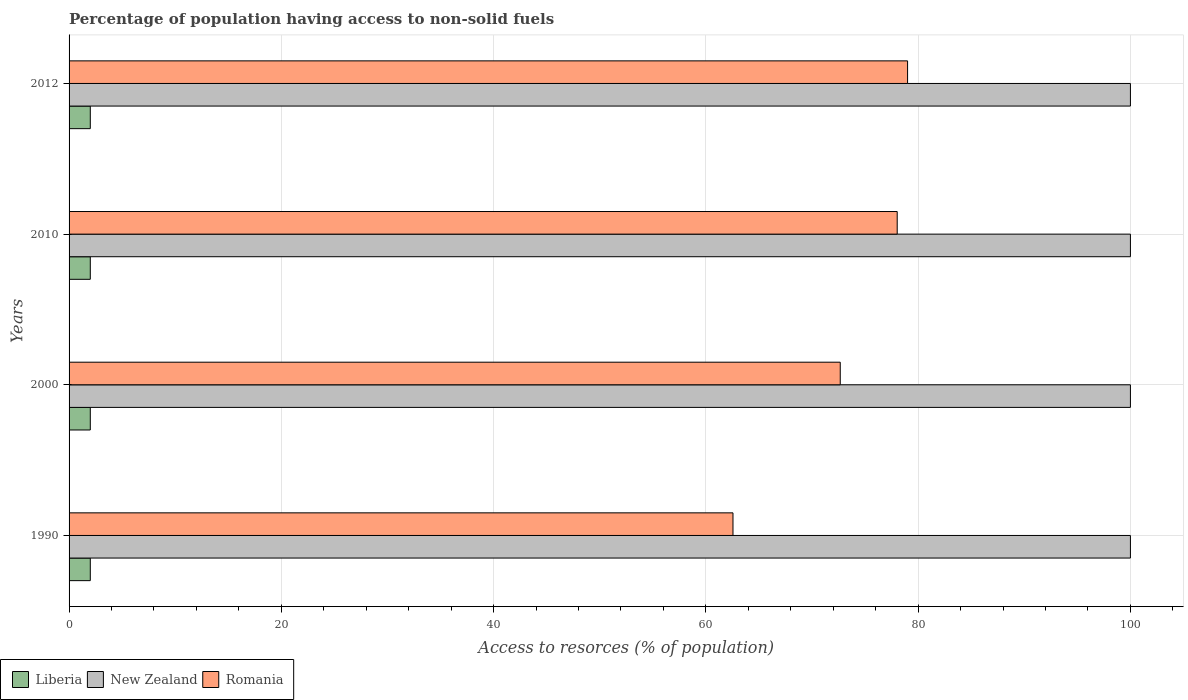How many different coloured bars are there?
Offer a very short reply. 3. How many groups of bars are there?
Keep it short and to the point. 4. Are the number of bars on each tick of the Y-axis equal?
Your answer should be compact. Yes. What is the label of the 2nd group of bars from the top?
Your answer should be compact. 2010. In how many cases, is the number of bars for a given year not equal to the number of legend labels?
Offer a terse response. 0. What is the percentage of population having access to non-solid fuels in Liberia in 2010?
Your response must be concise. 2. Across all years, what is the maximum percentage of population having access to non-solid fuels in Liberia?
Offer a very short reply. 2. Across all years, what is the minimum percentage of population having access to non-solid fuels in Romania?
Offer a very short reply. 62.55. In which year was the percentage of population having access to non-solid fuels in Liberia maximum?
Make the answer very short. 1990. In which year was the percentage of population having access to non-solid fuels in New Zealand minimum?
Make the answer very short. 1990. What is the total percentage of population having access to non-solid fuels in Liberia in the graph?
Your answer should be compact. 8. What is the difference between the percentage of population having access to non-solid fuels in Romania in 2010 and the percentage of population having access to non-solid fuels in Liberia in 2012?
Make the answer very short. 76.03. In the year 2000, what is the difference between the percentage of population having access to non-solid fuels in New Zealand and percentage of population having access to non-solid fuels in Romania?
Your answer should be very brief. 27.34. In how many years, is the percentage of population having access to non-solid fuels in Romania greater than 60 %?
Provide a short and direct response. 4. What is the ratio of the percentage of population having access to non-solid fuels in New Zealand in 1990 to that in 2000?
Keep it short and to the point. 1. Is the percentage of population having access to non-solid fuels in New Zealand in 1990 less than that in 2012?
Make the answer very short. No. Is the difference between the percentage of population having access to non-solid fuels in New Zealand in 2000 and 2010 greater than the difference between the percentage of population having access to non-solid fuels in Romania in 2000 and 2010?
Provide a succinct answer. Yes. What is the difference between the highest and the second highest percentage of population having access to non-solid fuels in New Zealand?
Provide a succinct answer. 0. What is the difference between the highest and the lowest percentage of population having access to non-solid fuels in Liberia?
Make the answer very short. 0. What does the 1st bar from the top in 2012 represents?
Keep it short and to the point. Romania. What does the 2nd bar from the bottom in 2000 represents?
Provide a succinct answer. New Zealand. Is it the case that in every year, the sum of the percentage of population having access to non-solid fuels in New Zealand and percentage of population having access to non-solid fuels in Romania is greater than the percentage of population having access to non-solid fuels in Liberia?
Your answer should be very brief. Yes. How many years are there in the graph?
Give a very brief answer. 4. Are the values on the major ticks of X-axis written in scientific E-notation?
Offer a terse response. No. Does the graph contain grids?
Provide a succinct answer. Yes. Where does the legend appear in the graph?
Your answer should be very brief. Bottom left. What is the title of the graph?
Your response must be concise. Percentage of population having access to non-solid fuels. What is the label or title of the X-axis?
Offer a terse response. Access to resorces (% of population). What is the Access to resorces (% of population) in Liberia in 1990?
Offer a very short reply. 2. What is the Access to resorces (% of population) of New Zealand in 1990?
Your response must be concise. 100. What is the Access to resorces (% of population) in Romania in 1990?
Make the answer very short. 62.55. What is the Access to resorces (% of population) of Liberia in 2000?
Offer a very short reply. 2. What is the Access to resorces (% of population) in New Zealand in 2000?
Give a very brief answer. 100. What is the Access to resorces (% of population) in Romania in 2000?
Your response must be concise. 72.66. What is the Access to resorces (% of population) in Liberia in 2010?
Offer a terse response. 2. What is the Access to resorces (% of population) in New Zealand in 2010?
Your answer should be very brief. 100. What is the Access to resorces (% of population) of Romania in 2010?
Your response must be concise. 78.03. What is the Access to resorces (% of population) in Liberia in 2012?
Provide a succinct answer. 2. What is the Access to resorces (% of population) in New Zealand in 2012?
Offer a terse response. 100. What is the Access to resorces (% of population) of Romania in 2012?
Give a very brief answer. 79. Across all years, what is the maximum Access to resorces (% of population) of Liberia?
Provide a succinct answer. 2. Across all years, what is the maximum Access to resorces (% of population) of New Zealand?
Provide a succinct answer. 100. Across all years, what is the maximum Access to resorces (% of population) in Romania?
Make the answer very short. 79. Across all years, what is the minimum Access to resorces (% of population) of Liberia?
Provide a short and direct response. 2. Across all years, what is the minimum Access to resorces (% of population) in Romania?
Your response must be concise. 62.55. What is the total Access to resorces (% of population) of Romania in the graph?
Give a very brief answer. 292.24. What is the difference between the Access to resorces (% of population) of New Zealand in 1990 and that in 2000?
Provide a succinct answer. 0. What is the difference between the Access to resorces (% of population) in Romania in 1990 and that in 2000?
Ensure brevity in your answer.  -10.11. What is the difference between the Access to resorces (% of population) in Liberia in 1990 and that in 2010?
Ensure brevity in your answer.  0. What is the difference between the Access to resorces (% of population) in New Zealand in 1990 and that in 2010?
Offer a very short reply. 0. What is the difference between the Access to resorces (% of population) of Romania in 1990 and that in 2010?
Give a very brief answer. -15.47. What is the difference between the Access to resorces (% of population) in Liberia in 1990 and that in 2012?
Your answer should be very brief. 0. What is the difference between the Access to resorces (% of population) in New Zealand in 1990 and that in 2012?
Your answer should be very brief. 0. What is the difference between the Access to resorces (% of population) in Romania in 1990 and that in 2012?
Give a very brief answer. -16.45. What is the difference between the Access to resorces (% of population) of Liberia in 2000 and that in 2010?
Your response must be concise. 0. What is the difference between the Access to resorces (% of population) in New Zealand in 2000 and that in 2010?
Keep it short and to the point. 0. What is the difference between the Access to resorces (% of population) in Romania in 2000 and that in 2010?
Your answer should be very brief. -5.37. What is the difference between the Access to resorces (% of population) of Liberia in 2000 and that in 2012?
Ensure brevity in your answer.  0. What is the difference between the Access to resorces (% of population) in New Zealand in 2000 and that in 2012?
Provide a short and direct response. 0. What is the difference between the Access to resorces (% of population) in Romania in 2000 and that in 2012?
Your answer should be compact. -6.34. What is the difference between the Access to resorces (% of population) of Liberia in 2010 and that in 2012?
Your response must be concise. 0. What is the difference between the Access to resorces (% of population) of New Zealand in 2010 and that in 2012?
Give a very brief answer. 0. What is the difference between the Access to resorces (% of population) of Romania in 2010 and that in 2012?
Offer a terse response. -0.98. What is the difference between the Access to resorces (% of population) in Liberia in 1990 and the Access to resorces (% of population) in New Zealand in 2000?
Provide a succinct answer. -98. What is the difference between the Access to resorces (% of population) of Liberia in 1990 and the Access to resorces (% of population) of Romania in 2000?
Your answer should be compact. -70.66. What is the difference between the Access to resorces (% of population) of New Zealand in 1990 and the Access to resorces (% of population) of Romania in 2000?
Give a very brief answer. 27.34. What is the difference between the Access to resorces (% of population) of Liberia in 1990 and the Access to resorces (% of population) of New Zealand in 2010?
Provide a succinct answer. -98. What is the difference between the Access to resorces (% of population) of Liberia in 1990 and the Access to resorces (% of population) of Romania in 2010?
Make the answer very short. -76.03. What is the difference between the Access to resorces (% of population) of New Zealand in 1990 and the Access to resorces (% of population) of Romania in 2010?
Your response must be concise. 21.97. What is the difference between the Access to resorces (% of population) of Liberia in 1990 and the Access to resorces (% of population) of New Zealand in 2012?
Keep it short and to the point. -98. What is the difference between the Access to resorces (% of population) of Liberia in 1990 and the Access to resorces (% of population) of Romania in 2012?
Offer a very short reply. -77. What is the difference between the Access to resorces (% of population) in New Zealand in 1990 and the Access to resorces (% of population) in Romania in 2012?
Ensure brevity in your answer.  21. What is the difference between the Access to resorces (% of population) in Liberia in 2000 and the Access to resorces (% of population) in New Zealand in 2010?
Your response must be concise. -98. What is the difference between the Access to resorces (% of population) in Liberia in 2000 and the Access to resorces (% of population) in Romania in 2010?
Provide a succinct answer. -76.03. What is the difference between the Access to resorces (% of population) of New Zealand in 2000 and the Access to resorces (% of population) of Romania in 2010?
Keep it short and to the point. 21.97. What is the difference between the Access to resorces (% of population) in Liberia in 2000 and the Access to resorces (% of population) in New Zealand in 2012?
Provide a short and direct response. -98. What is the difference between the Access to resorces (% of population) of Liberia in 2000 and the Access to resorces (% of population) of Romania in 2012?
Your answer should be very brief. -77. What is the difference between the Access to resorces (% of population) of New Zealand in 2000 and the Access to resorces (% of population) of Romania in 2012?
Keep it short and to the point. 21. What is the difference between the Access to resorces (% of population) in Liberia in 2010 and the Access to resorces (% of population) in New Zealand in 2012?
Offer a terse response. -98. What is the difference between the Access to resorces (% of population) of Liberia in 2010 and the Access to resorces (% of population) of Romania in 2012?
Offer a very short reply. -77. What is the difference between the Access to resorces (% of population) of New Zealand in 2010 and the Access to resorces (% of population) of Romania in 2012?
Offer a very short reply. 21. What is the average Access to resorces (% of population) in Liberia per year?
Provide a short and direct response. 2. What is the average Access to resorces (% of population) of Romania per year?
Offer a very short reply. 73.06. In the year 1990, what is the difference between the Access to resorces (% of population) in Liberia and Access to resorces (% of population) in New Zealand?
Your answer should be very brief. -98. In the year 1990, what is the difference between the Access to resorces (% of population) of Liberia and Access to resorces (% of population) of Romania?
Your response must be concise. -60.55. In the year 1990, what is the difference between the Access to resorces (% of population) of New Zealand and Access to resorces (% of population) of Romania?
Your answer should be compact. 37.45. In the year 2000, what is the difference between the Access to resorces (% of population) in Liberia and Access to resorces (% of population) in New Zealand?
Make the answer very short. -98. In the year 2000, what is the difference between the Access to resorces (% of population) in Liberia and Access to resorces (% of population) in Romania?
Your answer should be compact. -70.66. In the year 2000, what is the difference between the Access to resorces (% of population) of New Zealand and Access to resorces (% of population) of Romania?
Provide a succinct answer. 27.34. In the year 2010, what is the difference between the Access to resorces (% of population) of Liberia and Access to resorces (% of population) of New Zealand?
Give a very brief answer. -98. In the year 2010, what is the difference between the Access to resorces (% of population) in Liberia and Access to resorces (% of population) in Romania?
Make the answer very short. -76.03. In the year 2010, what is the difference between the Access to resorces (% of population) in New Zealand and Access to resorces (% of population) in Romania?
Provide a short and direct response. 21.97. In the year 2012, what is the difference between the Access to resorces (% of population) of Liberia and Access to resorces (% of population) of New Zealand?
Give a very brief answer. -98. In the year 2012, what is the difference between the Access to resorces (% of population) of Liberia and Access to resorces (% of population) of Romania?
Give a very brief answer. -77. In the year 2012, what is the difference between the Access to resorces (% of population) of New Zealand and Access to resorces (% of population) of Romania?
Offer a terse response. 21. What is the ratio of the Access to resorces (% of population) of Romania in 1990 to that in 2000?
Make the answer very short. 0.86. What is the ratio of the Access to resorces (% of population) of New Zealand in 1990 to that in 2010?
Your response must be concise. 1. What is the ratio of the Access to resorces (% of population) of Romania in 1990 to that in 2010?
Offer a very short reply. 0.8. What is the ratio of the Access to resorces (% of population) of Romania in 1990 to that in 2012?
Offer a terse response. 0.79. What is the ratio of the Access to resorces (% of population) in New Zealand in 2000 to that in 2010?
Make the answer very short. 1. What is the ratio of the Access to resorces (% of population) of Romania in 2000 to that in 2010?
Your answer should be very brief. 0.93. What is the ratio of the Access to resorces (% of population) of New Zealand in 2000 to that in 2012?
Offer a very short reply. 1. What is the ratio of the Access to resorces (% of population) of Romania in 2000 to that in 2012?
Provide a succinct answer. 0.92. What is the ratio of the Access to resorces (% of population) of Liberia in 2010 to that in 2012?
Offer a very short reply. 1. What is the ratio of the Access to resorces (% of population) in New Zealand in 2010 to that in 2012?
Provide a short and direct response. 1. What is the ratio of the Access to resorces (% of population) of Romania in 2010 to that in 2012?
Provide a short and direct response. 0.99. What is the difference between the highest and the second highest Access to resorces (% of population) in Liberia?
Your answer should be very brief. 0. What is the difference between the highest and the second highest Access to resorces (% of population) of New Zealand?
Offer a terse response. 0. What is the difference between the highest and the second highest Access to resorces (% of population) in Romania?
Provide a short and direct response. 0.98. What is the difference between the highest and the lowest Access to resorces (% of population) in Liberia?
Ensure brevity in your answer.  0. What is the difference between the highest and the lowest Access to resorces (% of population) of New Zealand?
Keep it short and to the point. 0. What is the difference between the highest and the lowest Access to resorces (% of population) of Romania?
Provide a short and direct response. 16.45. 